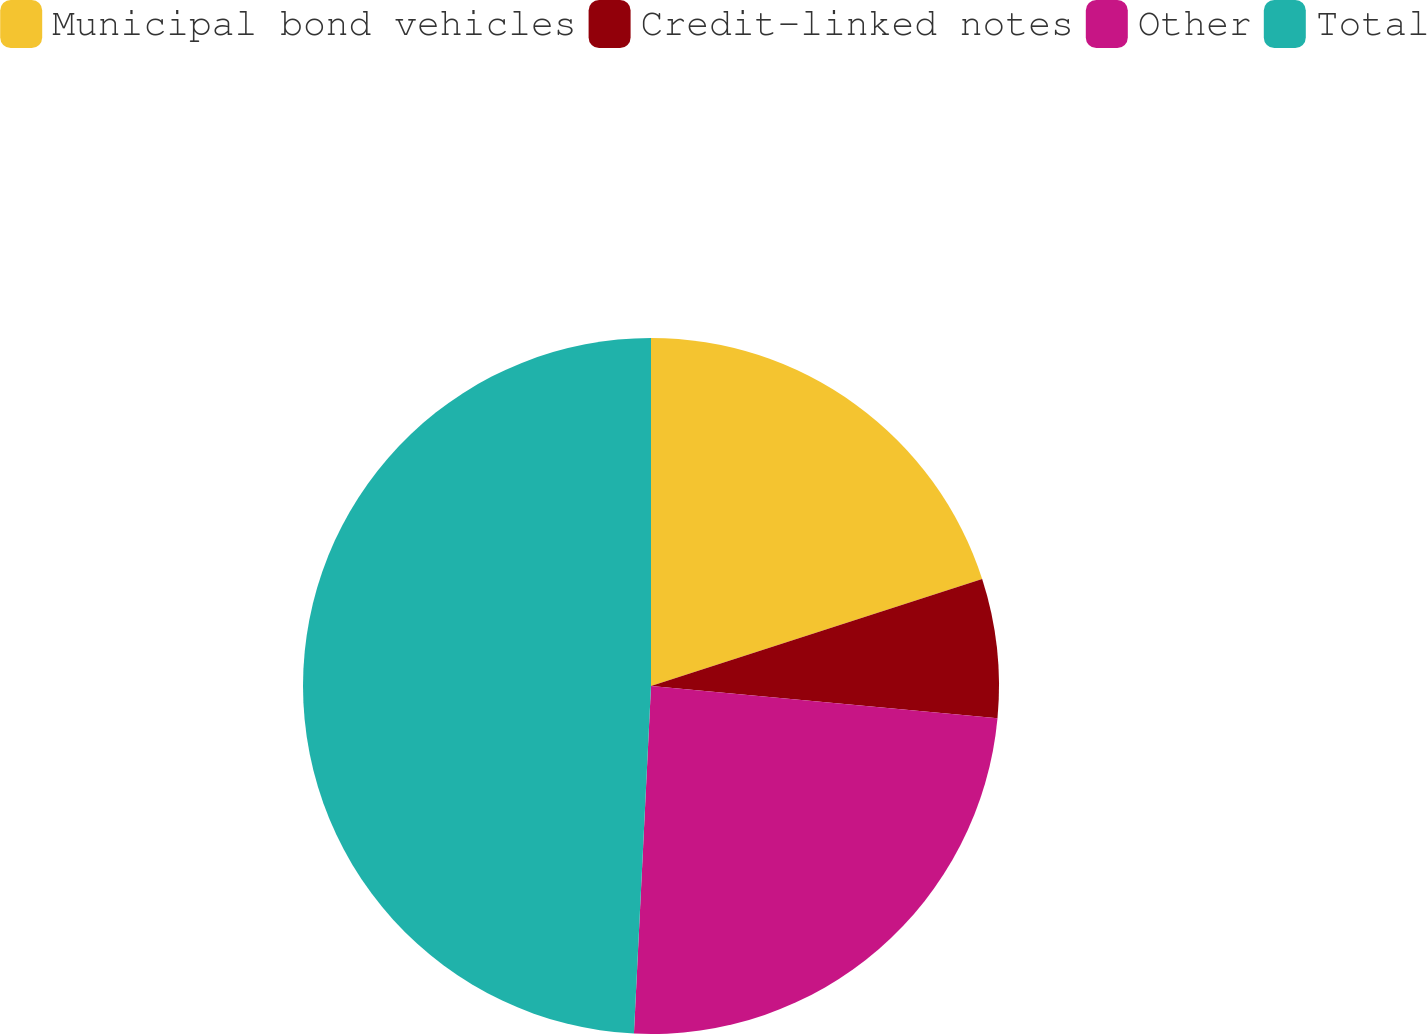Convert chart to OTSL. <chart><loc_0><loc_0><loc_500><loc_500><pie_chart><fcel>Municipal bond vehicles<fcel>Credit-linked notes<fcel>Other<fcel>Total<nl><fcel>20.03%<fcel>6.45%<fcel>24.3%<fcel>49.22%<nl></chart> 